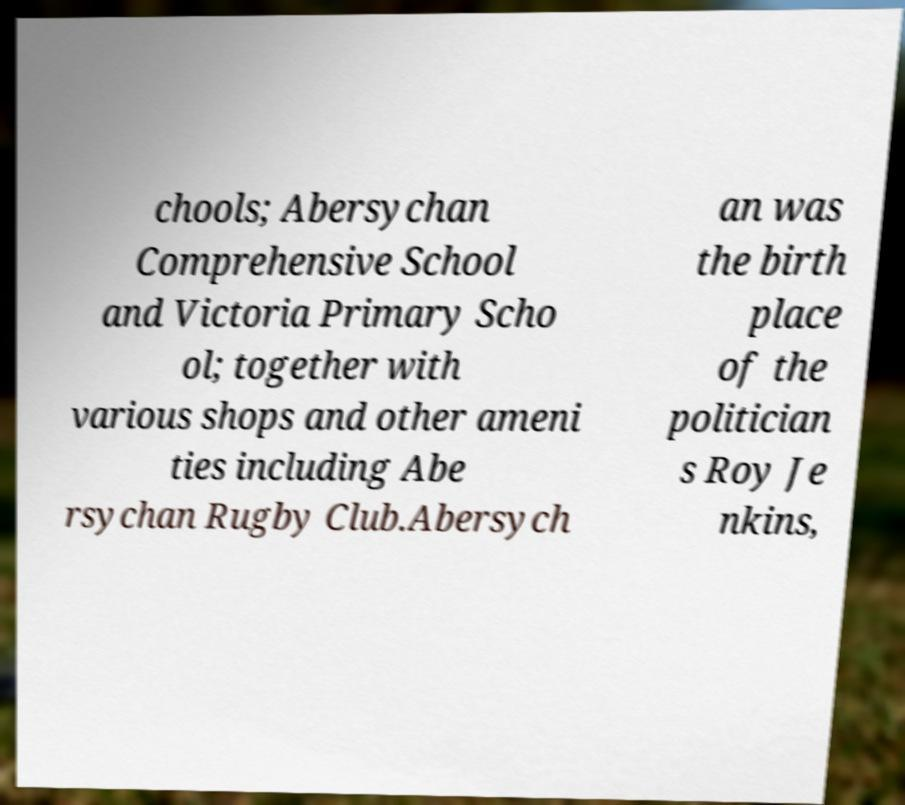I need the written content from this picture converted into text. Can you do that? chools; Abersychan Comprehensive School and Victoria Primary Scho ol; together with various shops and other ameni ties including Abe rsychan Rugby Club.Abersych an was the birth place of the politician s Roy Je nkins, 